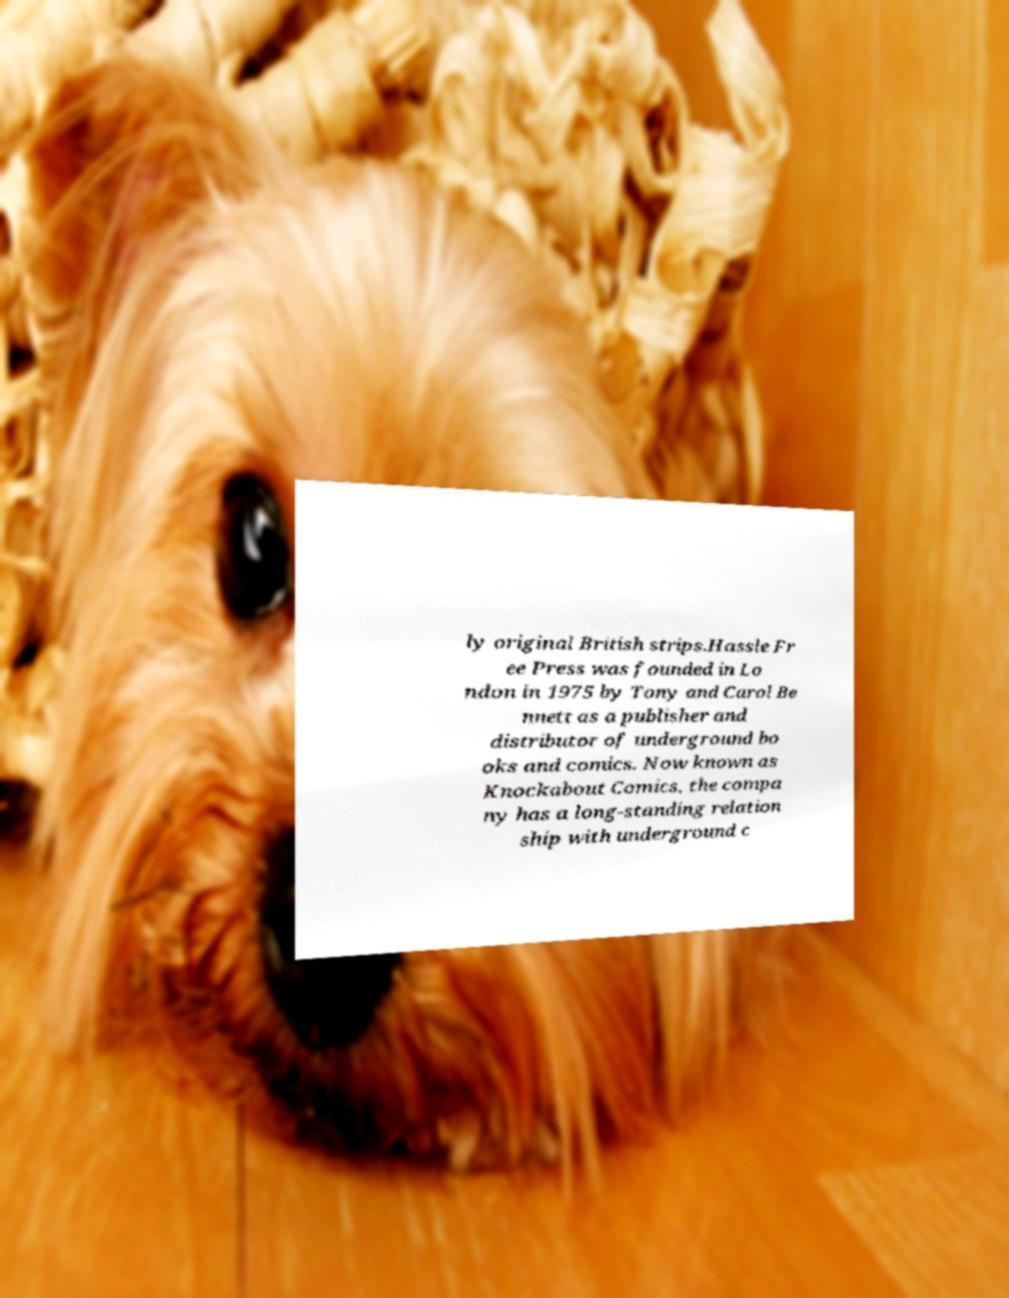Can you read and provide the text displayed in the image?This photo seems to have some interesting text. Can you extract and type it out for me? ly original British strips.Hassle Fr ee Press was founded in Lo ndon in 1975 by Tony and Carol Be nnett as a publisher and distributor of underground bo oks and comics. Now known as Knockabout Comics, the compa ny has a long-standing relation ship with underground c 